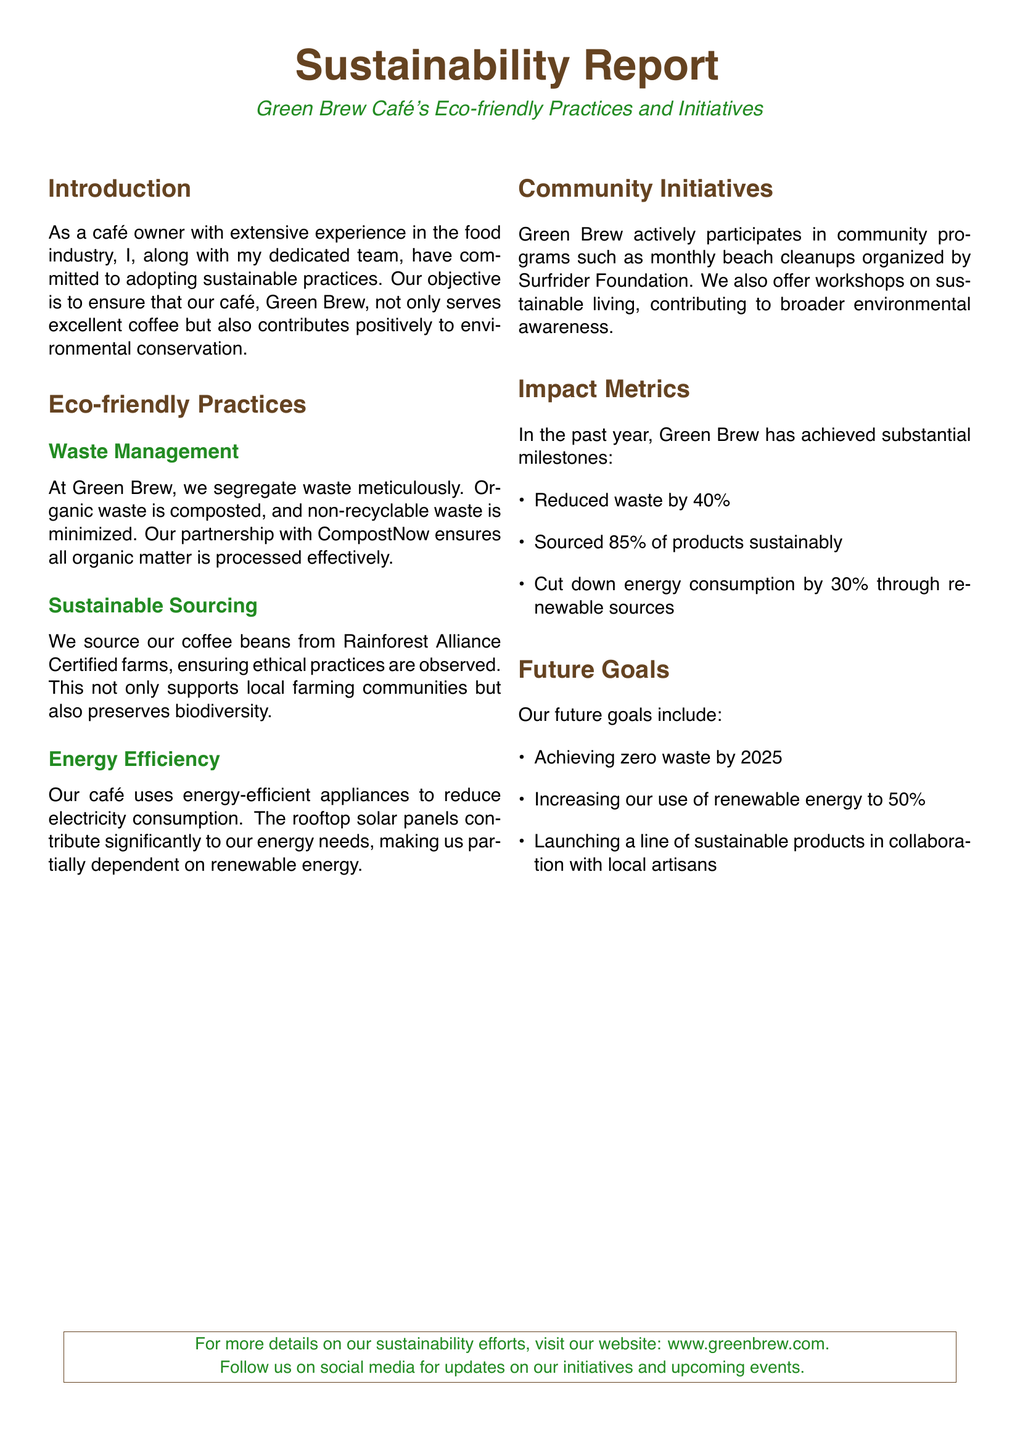What is the name of the café? The café's name is mentioned in the title, which is "Green Brew Café."
Answer: Green Brew Café What is the waste reduction percentage achieved? The document states that waste was reduced by 40%.
Answer: 40% What certification do the coffee beans have? The document indicates that the coffee beans are sourced from "Rainforest Alliance Certified" farms.
Answer: Rainforest Alliance Certified What is the target year for achieving zero waste? The document outlines the goal of achieving zero waste by 2025.
Answer: 2025 What organization does Green Brew partner with for waste management? The document specifies partnering with "CompostNow" for effective processing of organic waste.
Answer: CompostNow What is the percentage of products sourced sustainably? The text states that 85% of products are sourced sustainably.
Answer: 85% How much has energy consumption been cut down? The report mentions that energy consumption has been reduced by 30%.
Answer: 30% What community program does Green Brew participate in? The café participates in "monthly beach cleanups" organized by the Surfrider Foundation.
Answer: Monthly beach cleanups What is the future goal related to renewable energy usage? The document states the goal of increasing renewable energy use to 50%.
Answer: 50% 